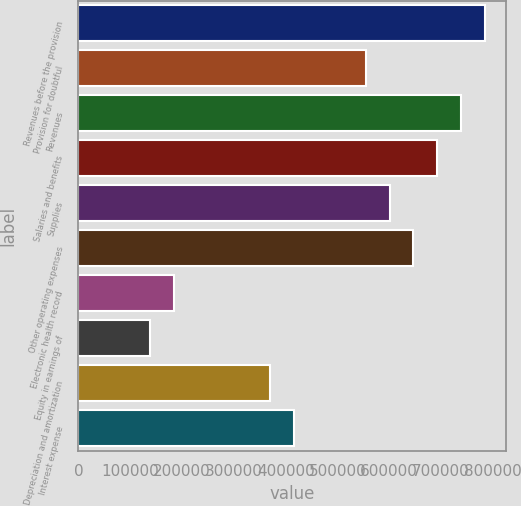Convert chart to OTSL. <chart><loc_0><loc_0><loc_500><loc_500><bar_chart><fcel>Revenues before the provision<fcel>Provision for doubtful<fcel>Revenues<fcel>Salaries and benefits<fcel>Supplies<fcel>Other operating expenses<fcel>Electronic health record<fcel>Equity in earnings of<fcel>Depreciation and amortization<fcel>Interest expense<nl><fcel>785250<fcel>554295<fcel>739059<fcel>692868<fcel>600486<fcel>646677<fcel>184767<fcel>138576<fcel>369531<fcel>415722<nl></chart> 